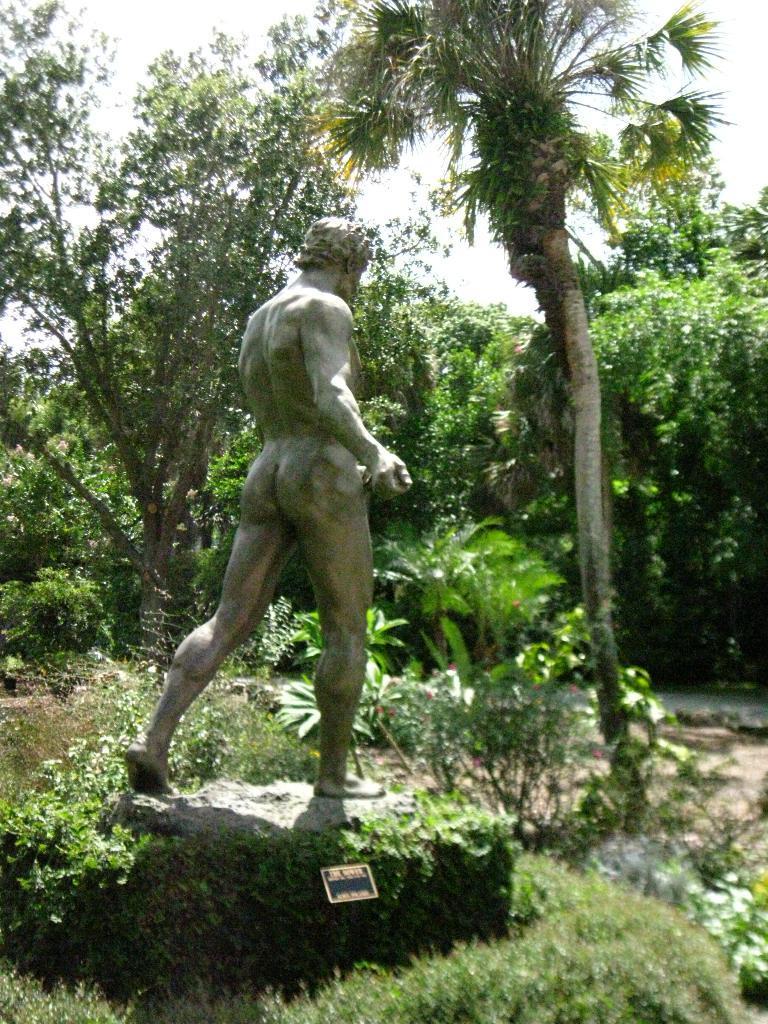Describe this image in one or two sentences. In this image in the middle I can see, a statue of a man standing on a rock and there are many trees around. 